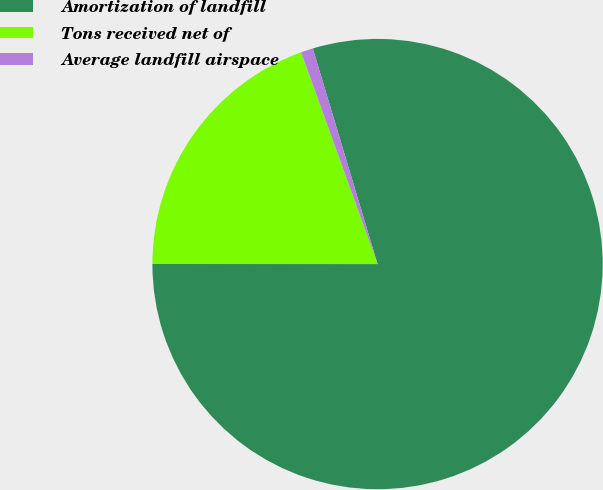Convert chart. <chart><loc_0><loc_0><loc_500><loc_500><pie_chart><fcel>Amortization of landfill<fcel>Tons received net of<fcel>Average landfill airspace<nl><fcel>79.64%<fcel>19.48%<fcel>0.87%<nl></chart> 